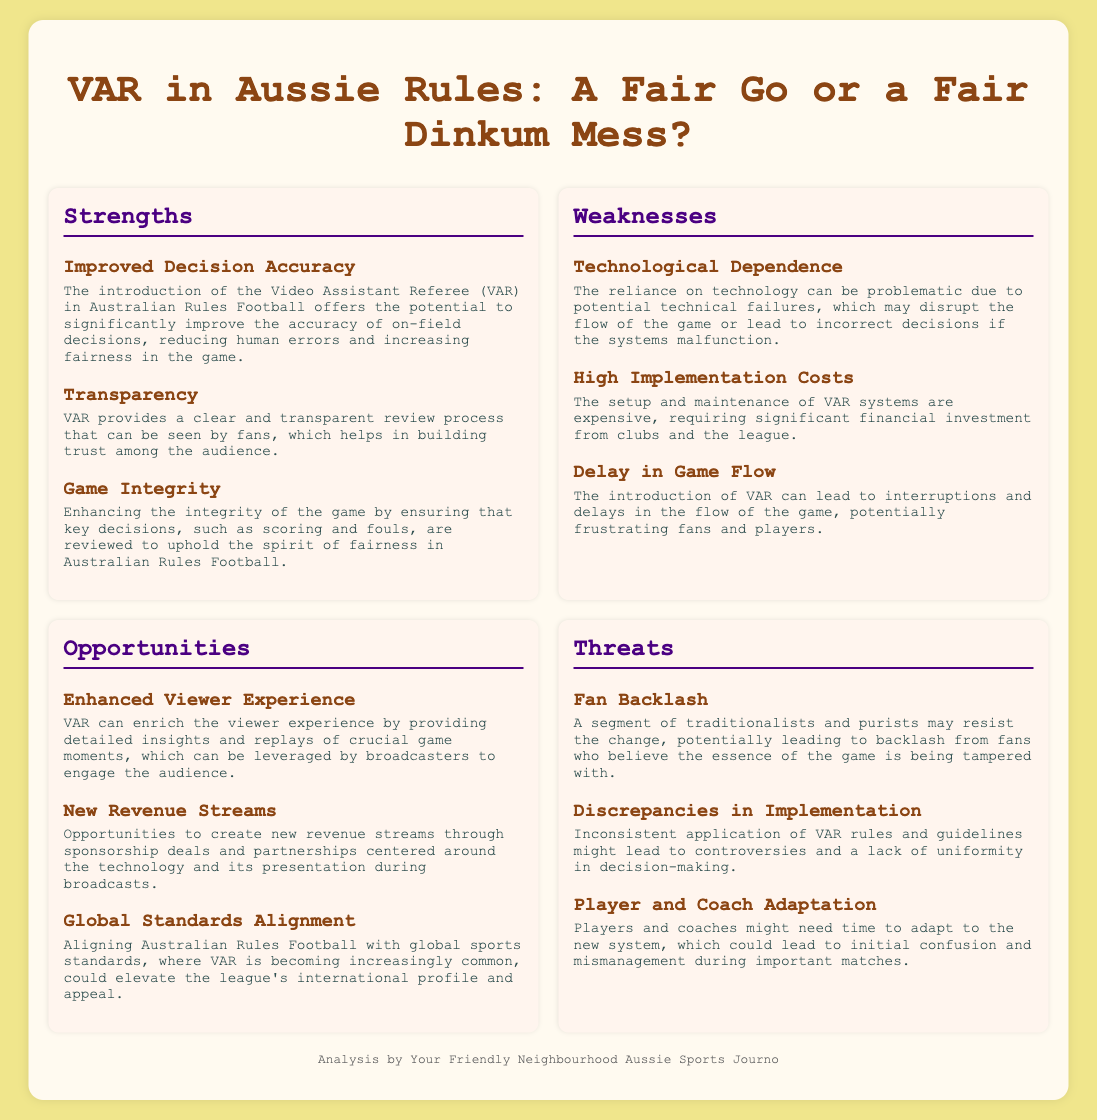What is the title of the document? The title of the document is found in the header section, which is "VAR in Aussie Rules: A Fair Go or a Fair Dinkum Mess?"
Answer: VAR in Aussie Rules: A Fair Go or a Fair Dinkum Mess? How many strengths are listed in the SWOT analysis? The document contains a section titled "Strengths," which includes a total of three strengths.
Answer: 3 What is one of the weaknesses related to the implementation of VAR? The document provides various weaknesses, including one specifically focused on technological dependence.
Answer: Technological Dependence What opportunity relates to revenue in the SWOT analysis? There is an item listed under Opportunities about new revenue streams created through sponsorship deals.
Answer: New Revenue Streams What threat involves fan reaction to VAR? The document mentions a potential backlash from fans as a threat posed by the introduction of VAR.
Answer: Fan Backlash What is a reason for improved decision accuracy? The document states that VAR offers the potential to significantly improve the accuracy of on-field decisions as a strength.
Answer: Improved Decision Accuracy What is a concern regarding game flow mentioned in the weaknesses? One of the weaknesses notes that the introduction of VAR can lead to delays in game flow, which is a concern.
Answer: Delay in Game Flow How many items are listed under Opportunities? The Opportunities section features three distinct items highlighting potential benefits of VAR.
Answer: 3 What effect does VAR aim to have on game integrity? The document highlights enhancing the integrity of the game as a strength associated with the introduction of VAR.
Answer: Game Integrity 